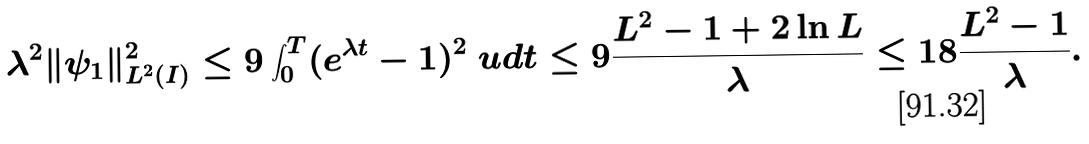<formula> <loc_0><loc_0><loc_500><loc_500>& \lambda ^ { 2 } \| \psi _ { 1 } \| _ { L ^ { 2 } ( I ) } ^ { 2 } \leq 9 \int _ { 0 } ^ { T } ( e ^ { \lambda t } - 1 ) ^ { 2 } \ u d t \leq 9 \frac { L ^ { 2 } - 1 + 2 \ln L } { \lambda } \leq 1 8 \frac { L ^ { 2 } - 1 } { \lambda } .</formula> 